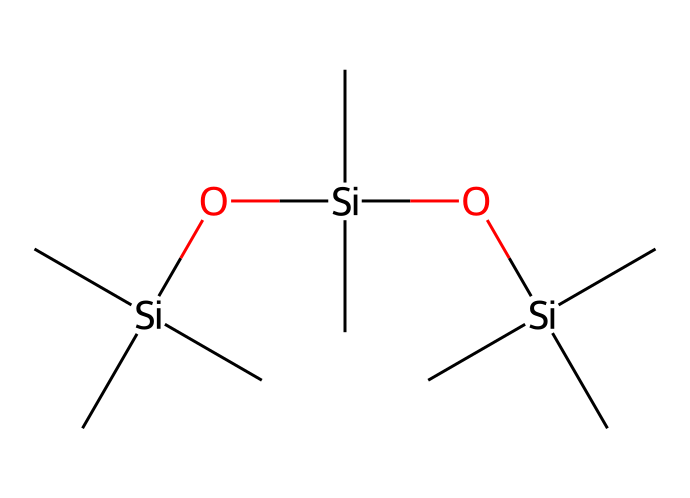What type of chemical is represented by the SMILES? The SMILES code indicates a silane-based compound, characterized by silicon atoms and connected hydrocarbon chains.
Answer: silane How many silicon atoms are present in the structure? By examining the SMILES, there are three silicon (Si) atoms present, as indicated by the occurrences of "Si" in the structure.
Answer: three What is the total number of carbon atoms in this chemical structure? The SMILES includes three occurrences of "C" attached to each silicon, as well as three additional carbon atoms from the terminal groups; thus, there are nine carbon (C) atoms total.
Answer: nine How many oxygen atoms are present in this SMILES? In the given SMILES, there are two occurrences of "O," indicating that there are two oxygen atoms present in the chemical structure.
Answer: two What functional groups are indicated in the structure? The presence of “O” signifies the inclusion of siloxane linkages (Si-O-Si) which constitute the water-repellent properties.
Answer: siloxane linkages How do the branching carbon chains affect the properties of this silane? The branched carbon chains contribute to the hydrophobic nature of the silane, enhancing its water-repellent properties, which is crucial for soccer uniforms.
Answer: enhance hydrophobicity How does the presence of oxygen affect the reactivity of this silane compound? The oxygen atoms facilitate siloxane bond formation, which makes the silane more reactive and enhances its functionality as a water repellent.
Answer: increases reactivity 